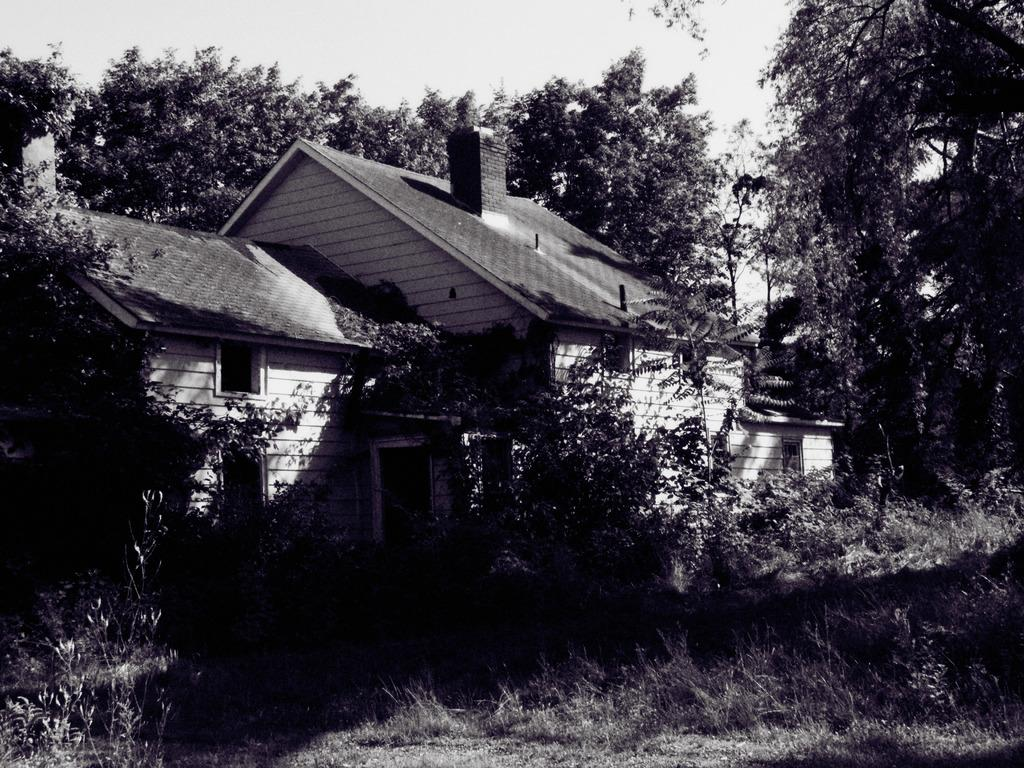What type of surface is at the bottom of the image? There is grass on the surface at the bottom of the image. What structure is located in the center of the image? There is a building in the center of the image. What can be seen in the background of the image? There are trees and the sky visible in the background of the image. How many snails can be seen controlling the building in the image? There are no snails present in the image, and they are not controlling the building. 